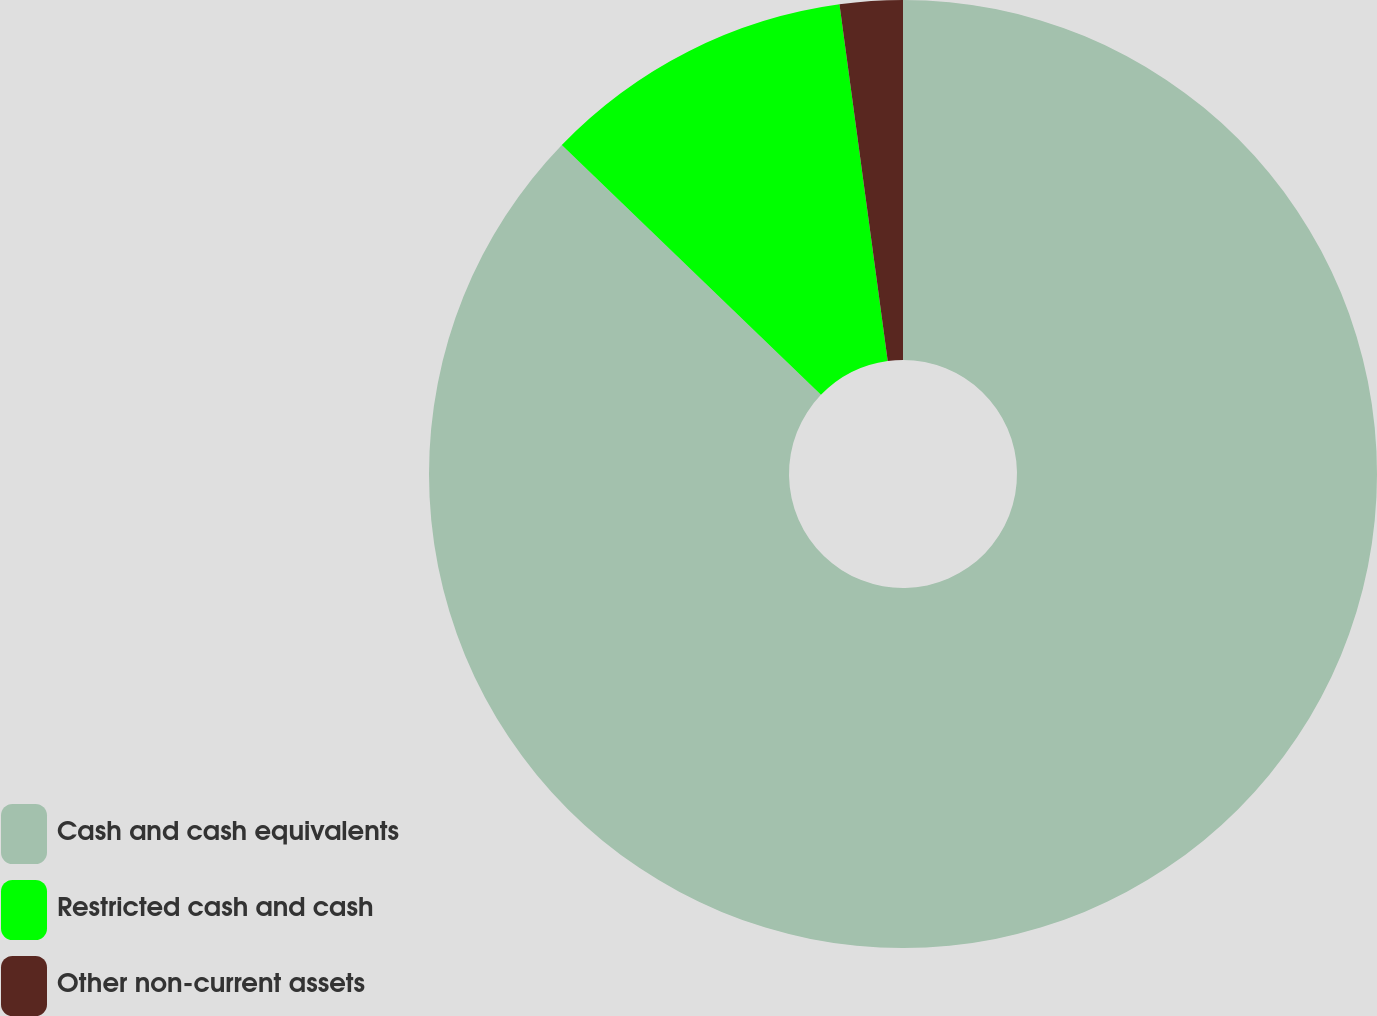Convert chart to OTSL. <chart><loc_0><loc_0><loc_500><loc_500><pie_chart><fcel>Cash and cash equivalents<fcel>Restricted cash and cash<fcel>Other non-current assets<nl><fcel>87.22%<fcel>10.65%<fcel>2.14%<nl></chart> 